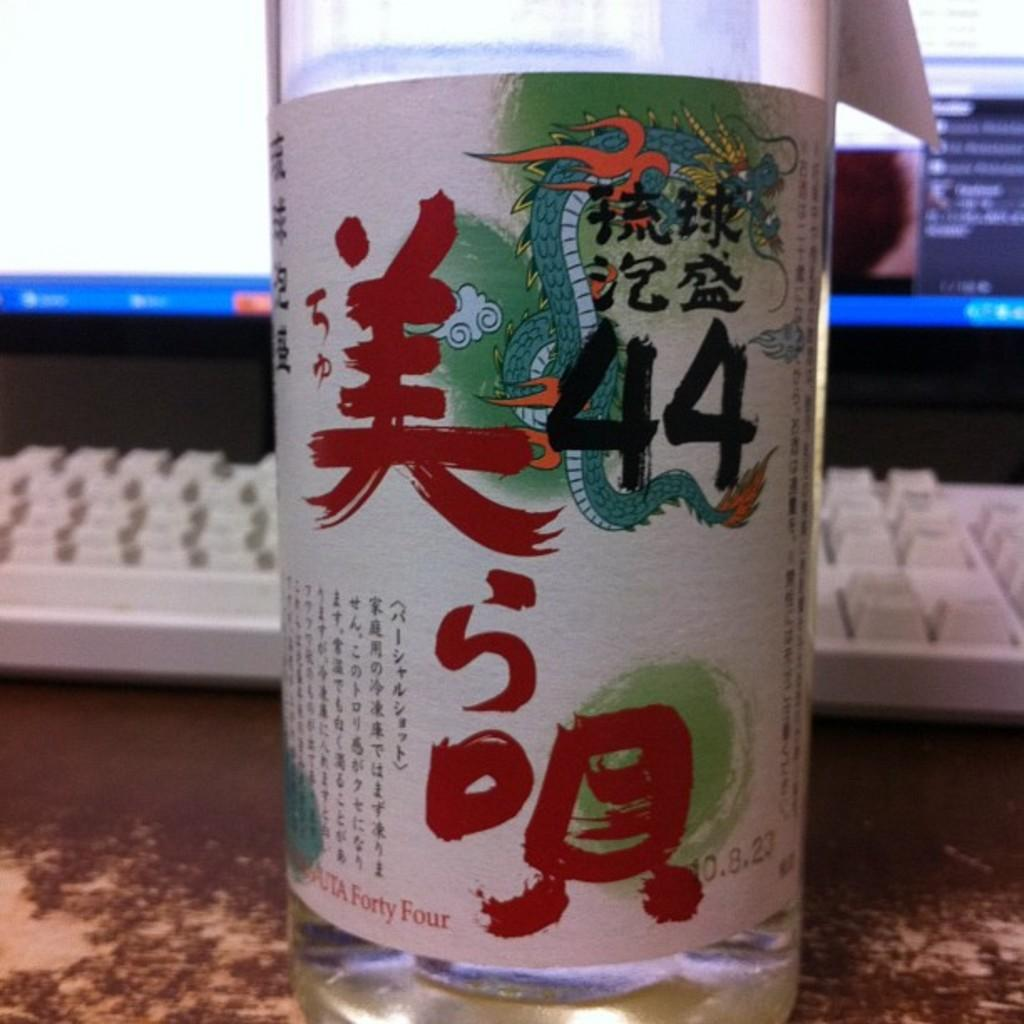<image>
Create a compact narrative representing the image presented. a label written in Japanese with the number 44 on it 